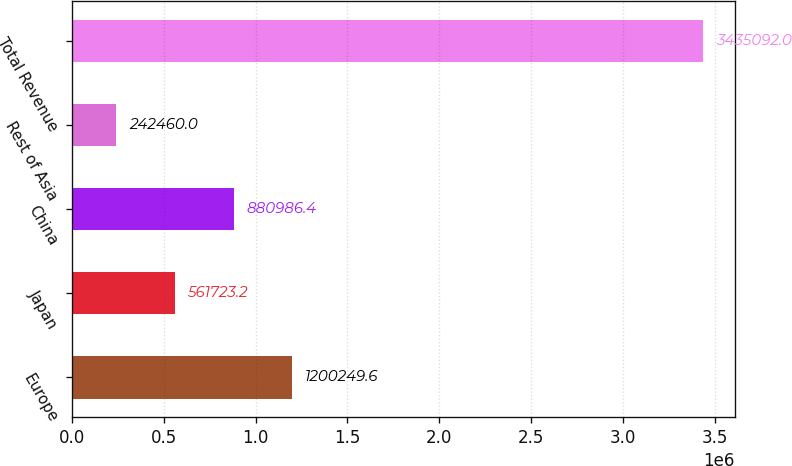Convert chart. <chart><loc_0><loc_0><loc_500><loc_500><bar_chart><fcel>Europe<fcel>Japan<fcel>China<fcel>Rest of Asia<fcel>Total Revenue<nl><fcel>1.20025e+06<fcel>561723<fcel>880986<fcel>242460<fcel>3.43509e+06<nl></chart> 